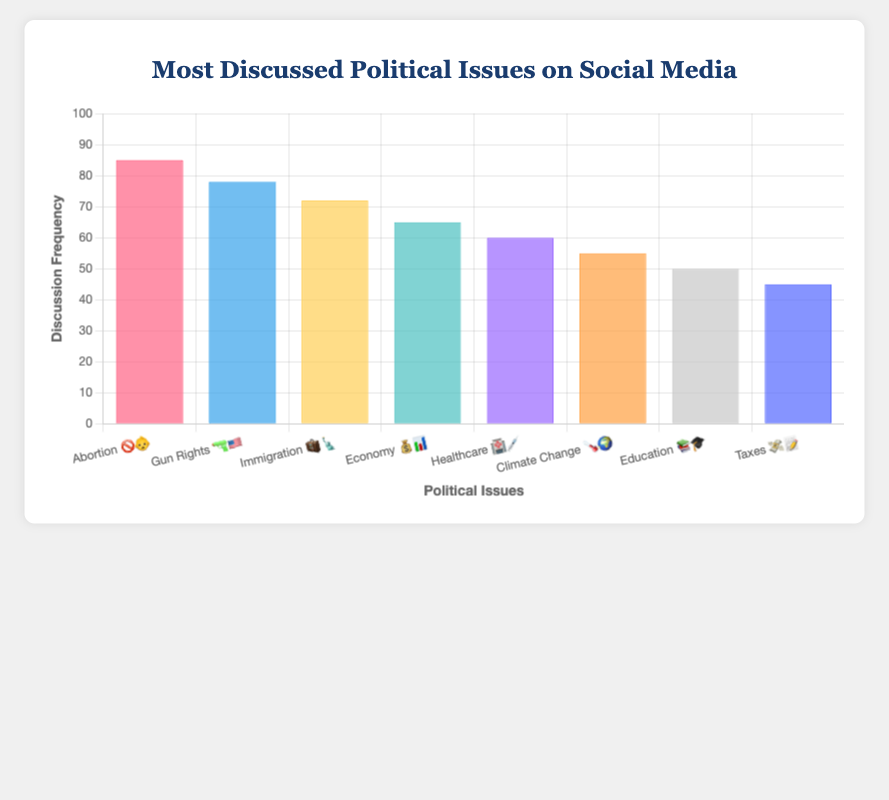Which political issue has the highest discussion frequency? The highest bar on the chart, labeled 'Abortion 🚫👶', corresponds to the political issue with the highest discussion frequency.
Answer: Abortion What is the discussion frequency for Gun Rights 🔫🇺🇸? The bar corresponding to 'Gun Rights 🔫🇺🇸' indicates a frequency of 78.
Answer: 78 Which issue has the lowest discussion frequency? The shortest bar on the chart is labeled 'Taxes 💸📝', representing the issue with the lowest discussion frequency.
Answer: Taxes How much higher is the discussion frequency for Abortion 🚫👶 compared to Taxes 💸📝? The frequency for Abortion is 85 and for Taxes is 45. The difference is 85 - 45 = 40.
Answer: 40 What is the average discussion frequency of all the issues? Sum the frequencies (85, 78, 72, 65, 60, 55, 50, 45) to get 510. Divide by the number of issues (8): 510 / 8 = 63.75.
Answer: 63.75 Which two issues have discussion frequencies closest to each other? 'Economy 💰📊' has a frequency of 65 and 'Healthcare 🏥💉' has a frequency of 60, with a difference of 5. This is the smallest difference between any two frequencies.
Answer: Economy and Healthcare How many issues have a discussion frequency above 70? 'Abortion 🚫👶', 'Gun Rights 🔫🇺🇸', and 'Immigration 🧳🗽' have frequencies above 70. Count these three issues.
Answer: 3 Which political issue represents the median discussion frequency? With eight issues, the median is the average of the 4th and 5th highest frequencies. These are 'Economy 💰📊' with 65 and 'Healthcare 🏥💉' with 60. Average is (65 + 60) / 2 = 62.5.
Answer: No single issue, median frequency 62.5 What is the combined discussion frequency for Climate Change 🌡️🌍 and Education 📚🎓? Add the frequencies for Climate Change (55) and Education (50): 55 + 50 = 105.
Answer: 105 